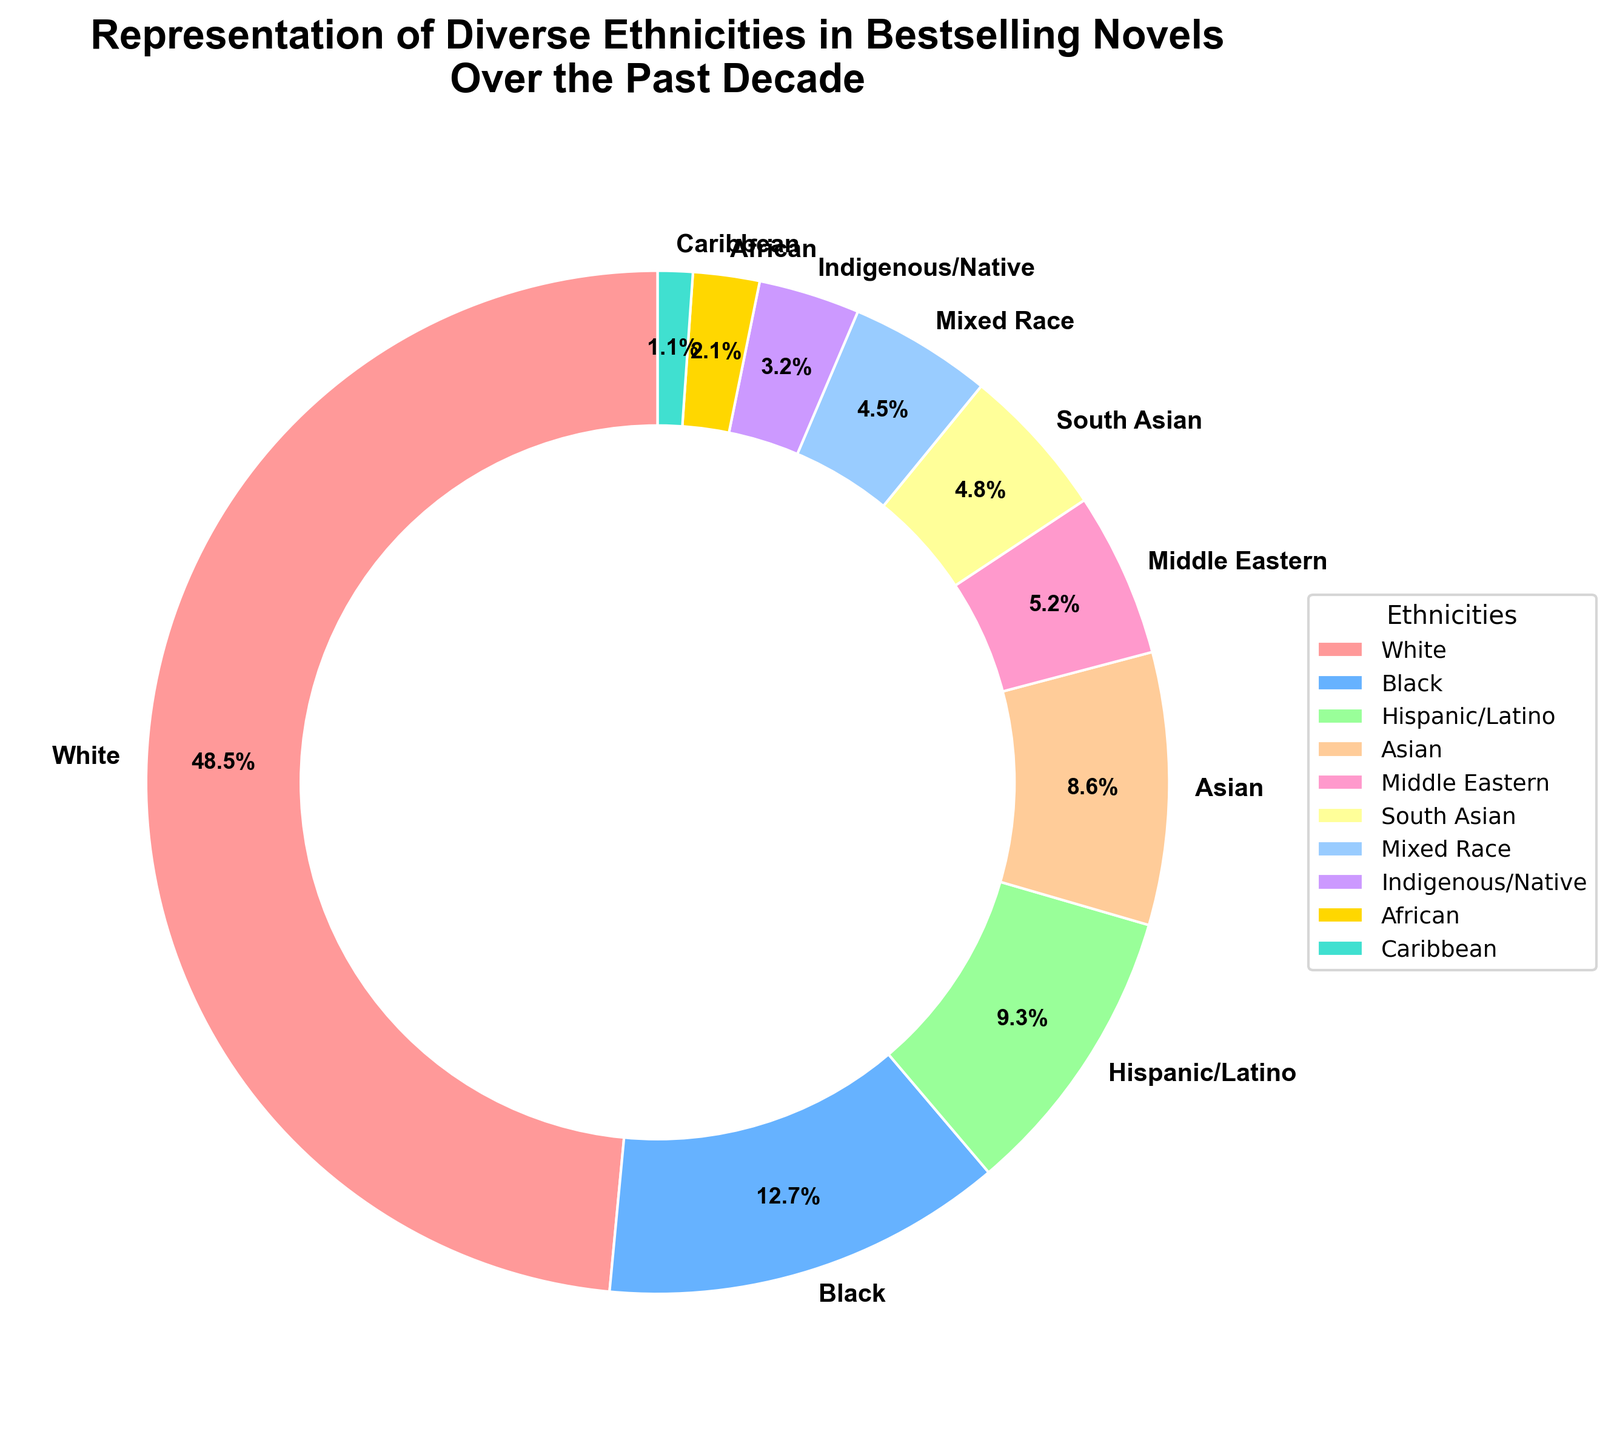What's the percentage of novels with White or Black characters combined? The percentage of novels with White characters is 48.5%, and with Black characters is 12.7%. Adding them together gives 48.5 + 12.7 = 61.2%.
Answer: 61.2% Which ethnicity has the highest representation in bestselling novels over the past decade? By looking at the percentages for all ethnicities, White characters have the highest representation at 48.5%.
Answer: White Which ethnicity has the second-lowest representation in the data? The data shows the following representations from lowest to highest: Caribbean (1.1%), African (2.1%), Indigenous/Native (3.2%), Mixed Race (4.5%), South Asian (4.8%), Middle Eastern (5.2%), Asian (8.6%), Hispanic/Latino (9.3%), Black (12.7%), and White (48.5%). The second-lowest representation is African at 2.1%.
Answer: African By what percentage do White characters exceed Asian characters in representation? The representation of White characters is 48.5%, and that of Asian characters is 8.6%. Subtracting gives 48.5 - 8.6 = 39.9%.
Answer: 39.9% How many ethnicities have a representation of less than 5%? Review the percentages: Caribbean (1.1%), African (2.1%), Indigenous/Native (3.2%), Mixed Race (4.5%), and South Asian (4.8%). There are 4 ethnicities (Caribbean, African, Indigenous/Native, and Mixed Race) with less than 5% representation.
Answer: 4 Which two ethnicities have the closest representation percentages, and what are those percentages? Reviewing the data, the closest values are South Asian at 4.8% and Mixed Race at 4.5%.
Answer: South Asian (4.8%) and Mixed Race (4.5%) Which ethnicities are represented by colors that can be described as shades of blue? The shades of blue correspond visually to Black (66B2FF) and Mixed Race (99CCFF)
Answer: Black and Mixed Race What is the sum of the representations of Hispanic/Latino, Asian, and Middle Eastern characters? The representations are Hispanic/Latino at 9.3%, Asian at 8.6%, and Middle Eastern at 5.2%. Adding them gives 9.3 + 8.6 + 5.2 = 23.1%.
Answer: 23.1% What is the combined representation percentage for all ethnicities except the White category? The total percentage for all categories is 100%. Subtracting the White category (48.5%) gives 100 - 48.5 = 51.5%.
Answer: 51.5% Which ethnicity has a representation closest to the average representation of all the listed ethnicities? To find the average, sum all percentages: 48.5 + 12.7 + 9.3 + 8.6 + 5.2 + 4.8 + 4.5 + 3.2 + 2.1 + 1.1 = 100%. The average is 100 / 10 = 10%. The closest ethnicity to this average is Hispanic/Latino at 9.3%.
Answer: Hispanic/Latino 